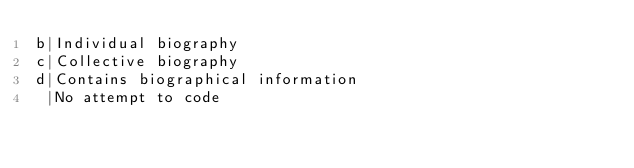Convert code to text. <code><loc_0><loc_0><loc_500><loc_500><_SQL_>b|Individual biography
c|Collective biography
d|Contains biographical information
 |No attempt to code
</code> 